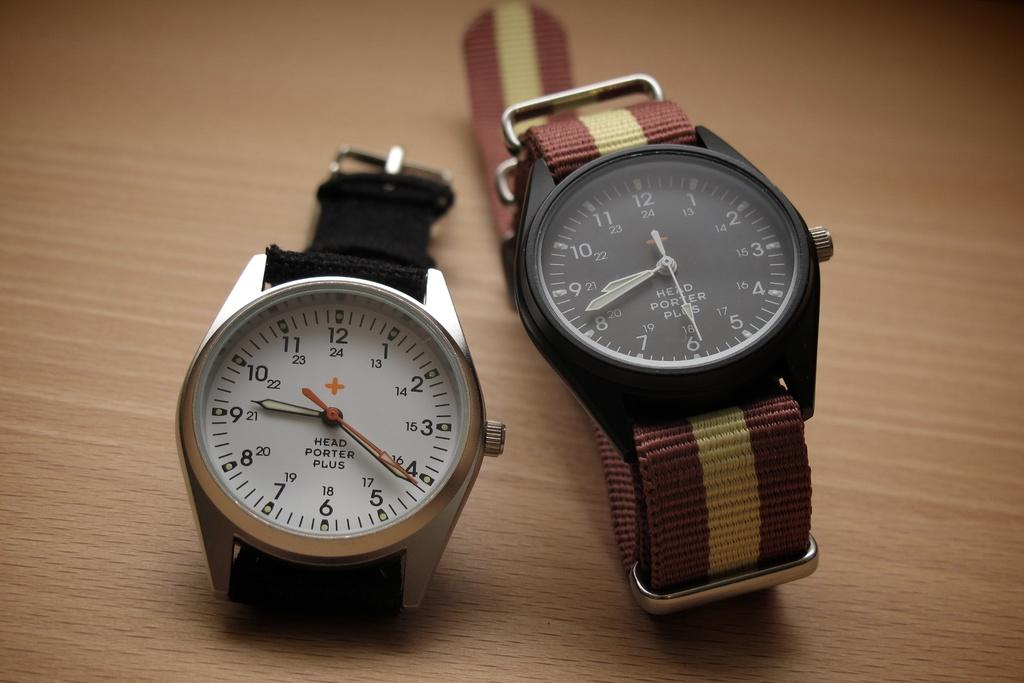<image>
Present a compact description of the photo's key features. Two watches, the one on the left reads Head Porter Plus. 